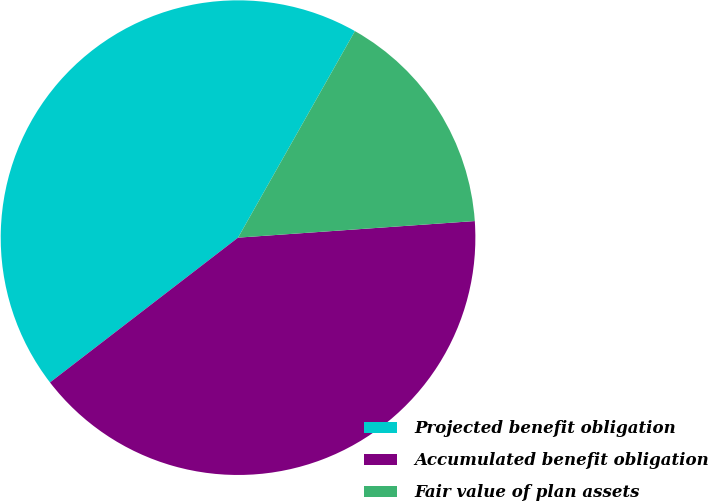Convert chart. <chart><loc_0><loc_0><loc_500><loc_500><pie_chart><fcel>Projected benefit obligation<fcel>Accumulated benefit obligation<fcel>Fair value of plan assets<nl><fcel>43.64%<fcel>40.67%<fcel>15.69%<nl></chart> 